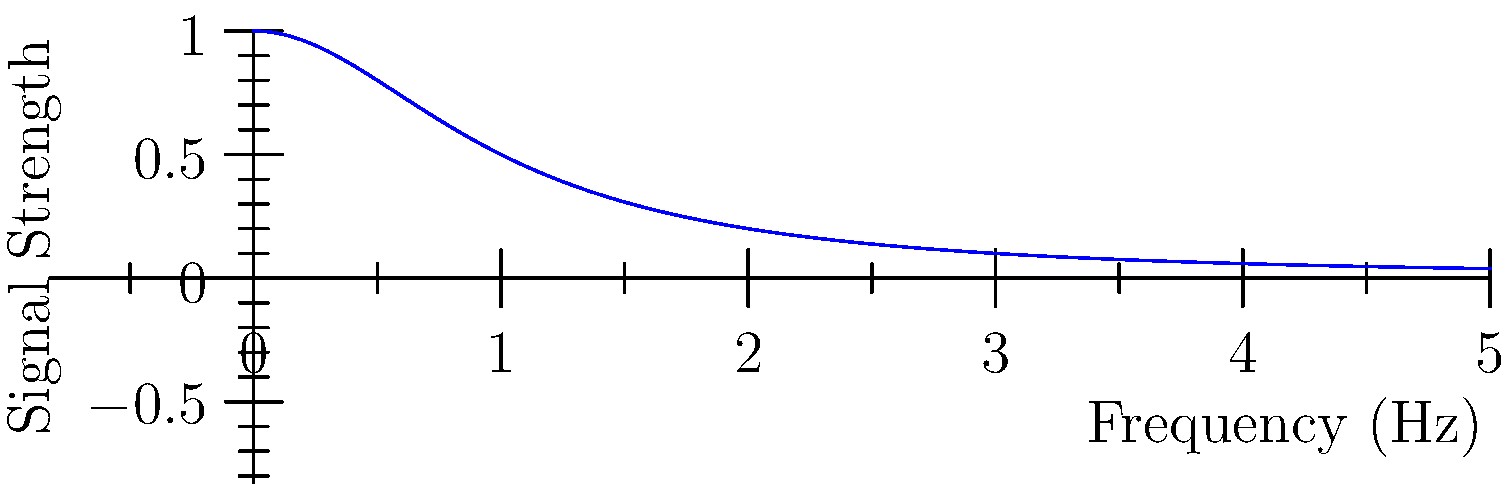Given the graph representing signal strength vs. frequency for different mobile network generations, explain why the trend contradicts the common belief that higher frequency bands (such as those used in 5G) provide better signal quality. How might this affect the future development of mobile networks? To answer this question, we need to analyze the graph and understand the relationship between frequency and signal strength in mobile networks:

1. Observation: The graph shows an inverse relationship between frequency and signal strength.

2. Physics principle: Higher frequencies in the electromagnetic spectrum have shorter wavelengths, which are more easily absorbed by obstacles and have difficulty penetrating buildings.

3. 3G, 4G, and 5G comparison:
   - 3G: Lowest frequency, highest signal strength
   - 4G: Medium frequency, medium signal strength
   - 5G: Highest frequency, lowest signal strength

4. Contradiction explanation: While higher frequencies allow for greater data capacity, they suffer from reduced signal strength and coverage area.

5. Impact on mobile network development:
   - Need for more base stations to compensate for reduced coverage
   - Increased infrastructure costs
   - Potential limitations in rural or densely populated urban areas

6. Future implications:
   - Research into advanced beamforming techniques
   - Development of hybrid networks combining multiple frequency bands
   - Exploration of alternative technologies for wide-area coverage

This trend suggests that the push towards ever-higher frequencies may not be sustainable for mobile networks, challenging the notion that mobile computing is advancing rapidly.
Answer: Higher frequencies offer increased data capacity but suffer from reduced signal strength and coverage, potentially limiting the advancement of mobile networks. 